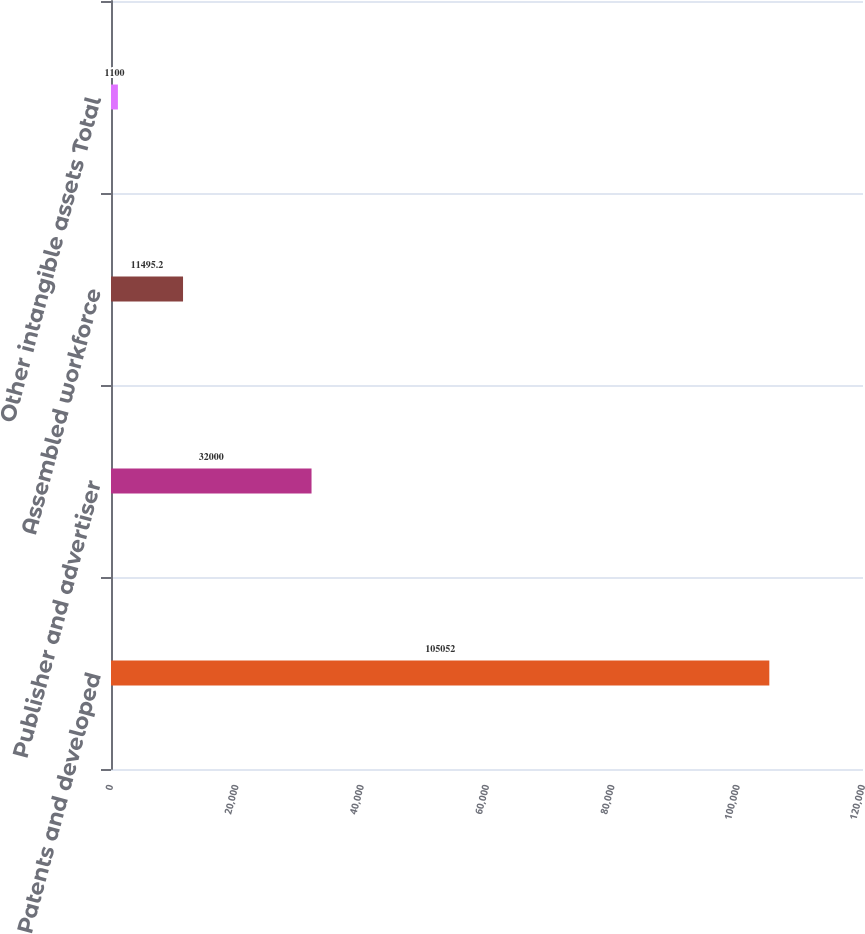Convert chart to OTSL. <chart><loc_0><loc_0><loc_500><loc_500><bar_chart><fcel>Patents and developed<fcel>Publisher and advertiser<fcel>Assembled workforce<fcel>Other intangible assets Total<nl><fcel>105052<fcel>32000<fcel>11495.2<fcel>1100<nl></chart> 